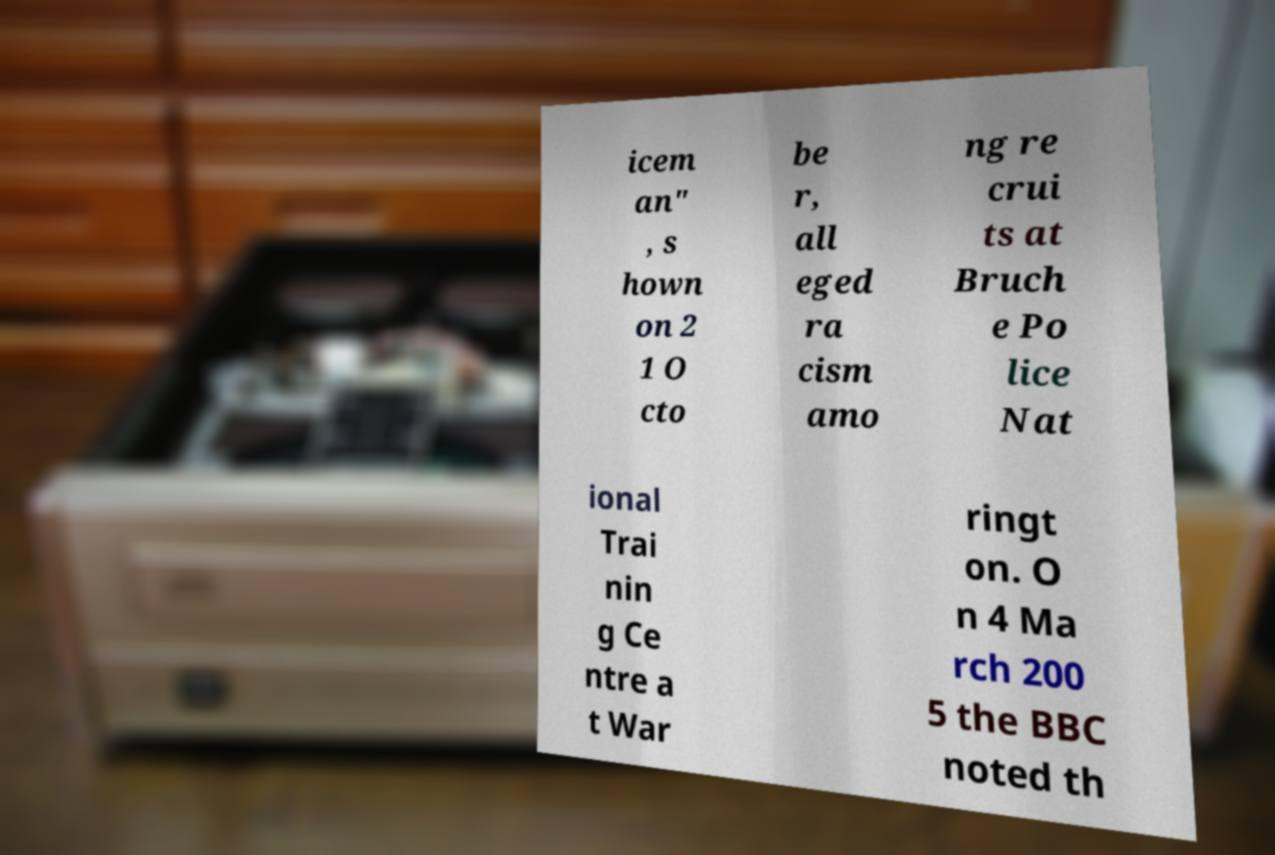Please read and relay the text visible in this image. What does it say? icem an" , s hown on 2 1 O cto be r, all eged ra cism amo ng re crui ts at Bruch e Po lice Nat ional Trai nin g Ce ntre a t War ringt on. O n 4 Ma rch 200 5 the BBC noted th 